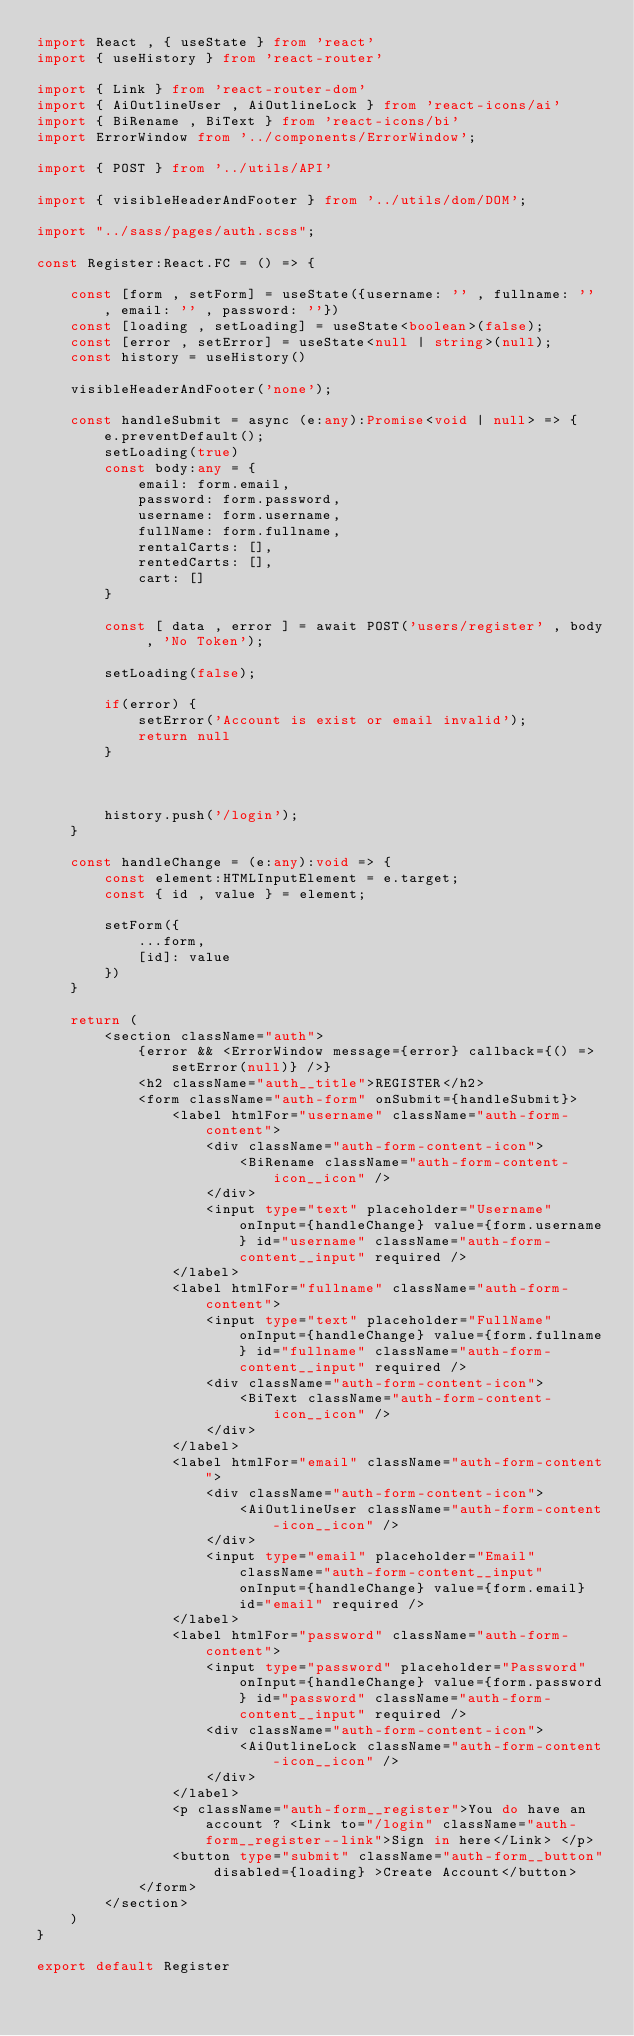<code> <loc_0><loc_0><loc_500><loc_500><_TypeScript_>import React , { useState } from 'react'
import { useHistory } from 'react-router'

import { Link } from 'react-router-dom'
import { AiOutlineUser , AiOutlineLock } from 'react-icons/ai'
import { BiRename , BiText } from 'react-icons/bi'
import ErrorWindow from '../components/ErrorWindow';

import { POST } from '../utils/API'

import { visibleHeaderAndFooter } from '../utils/dom/DOM';

import "../sass/pages/auth.scss";

const Register:React.FC = () => {

    const [form , setForm] = useState({username: '' , fullname: '' , email: '' , password: ''})
    const [loading , setLoading] = useState<boolean>(false);
    const [error , setError] = useState<null | string>(null);
    const history = useHistory()

    visibleHeaderAndFooter('none');

    const handleSubmit = async (e:any):Promise<void | null> => {
        e.preventDefault();
        setLoading(true)
        const body:any = {
            email: form.email,
            password: form.password,
            username: form.username,
            fullName: form.fullname,
            rentalCarts: [],
            rentedCarts: [],
            cart: []
        }

        const [ data , error ] = await POST('users/register' , body , 'No Token');
        
        setLoading(false);

        if(error) {
            setError('Account is exist or email invalid');
            return null
        }
        
        
        
        history.push('/login');
    }

    const handleChange = (e:any):void => {
        const element:HTMLInputElement = e.target;
        const { id , value } = element;

        setForm({
            ...form,
            [id]: value
        })
    }

    return (
        <section className="auth">
            {error && <ErrorWindow message={error} callback={() => setError(null)} />}
            <h2 className="auth__title">REGISTER</h2>
            <form className="auth-form" onSubmit={handleSubmit}>
                <label htmlFor="username" className="auth-form-content">
                    <div className="auth-form-content-icon">
                        <BiRename className="auth-form-content-icon__icon" />
                    </div>
                    <input type="text" placeholder="Username" onInput={handleChange} value={form.username} id="username" className="auth-form-content__input" required />
                </label>
                <label htmlFor="fullname" className="auth-form-content">
                    <input type="text" placeholder="FullName" onInput={handleChange} value={form.fullname} id="fullname" className="auth-form-content__input" required />
                    <div className="auth-form-content-icon">
                        <BiText className="auth-form-content-icon__icon" />
                    </div>
                </label>
                <label htmlFor="email" className="auth-form-content">
                    <div className="auth-form-content-icon">
                        <AiOutlineUser className="auth-form-content-icon__icon" />
                    </div>
                    <input type="email" placeholder="Email" className="auth-form-content__input"  onInput={handleChange} value={form.email} id="email" required />
                </label>
                <label htmlFor="password" className="auth-form-content">
                    <input type="password" placeholder="Password" onInput={handleChange} value={form.password} id="password" className="auth-form-content__input" required />
                    <div className="auth-form-content-icon">
                        <AiOutlineLock className="auth-form-content-icon__icon" />
                    </div>
                </label>
                <p className="auth-form__register">You do have an account ? <Link to="/login" className="auth-form__register--link">Sign in here</Link> </p>
                <button type="submit" className="auth-form__button" disabled={loading} >Create Account</button>
            </form>
        </section>
    )
}

export default Register
</code> 